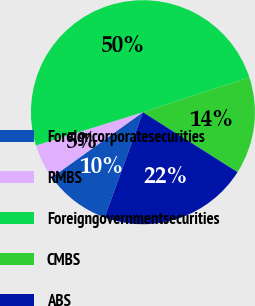<chart> <loc_0><loc_0><loc_500><loc_500><pie_chart><fcel>Foreigncorporatesecurities<fcel>RMBS<fcel>Foreigngovernmentsecurities<fcel>CMBS<fcel>ABS<nl><fcel>9.55%<fcel>5.09%<fcel>49.76%<fcel>14.02%<fcel>21.58%<nl></chart> 